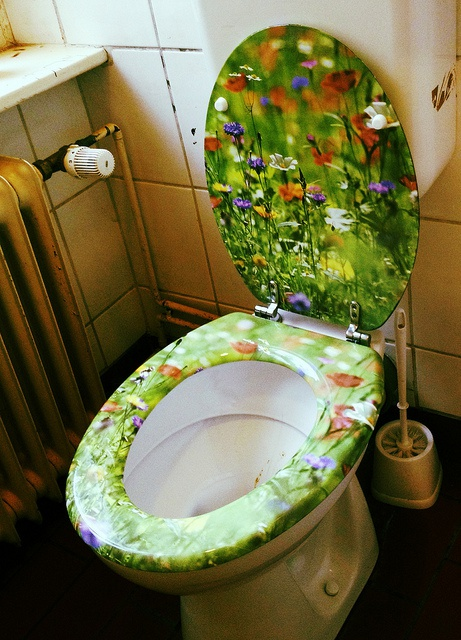Describe the objects in this image and their specific colors. I can see a toilet in tan, olive, beige, darkgray, and black tones in this image. 